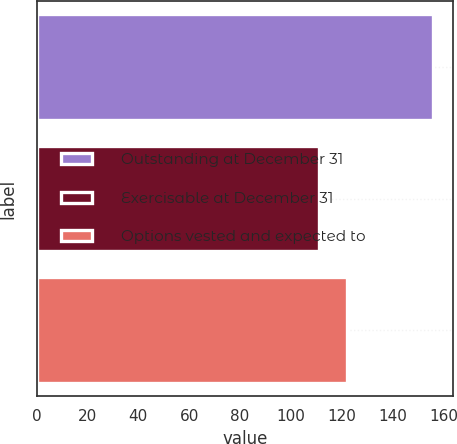Convert chart to OTSL. <chart><loc_0><loc_0><loc_500><loc_500><bar_chart><fcel>Outstanding at December 31<fcel>Exercisable at December 31<fcel>Options vested and expected to<nl><fcel>156<fcel>111<fcel>122<nl></chart> 